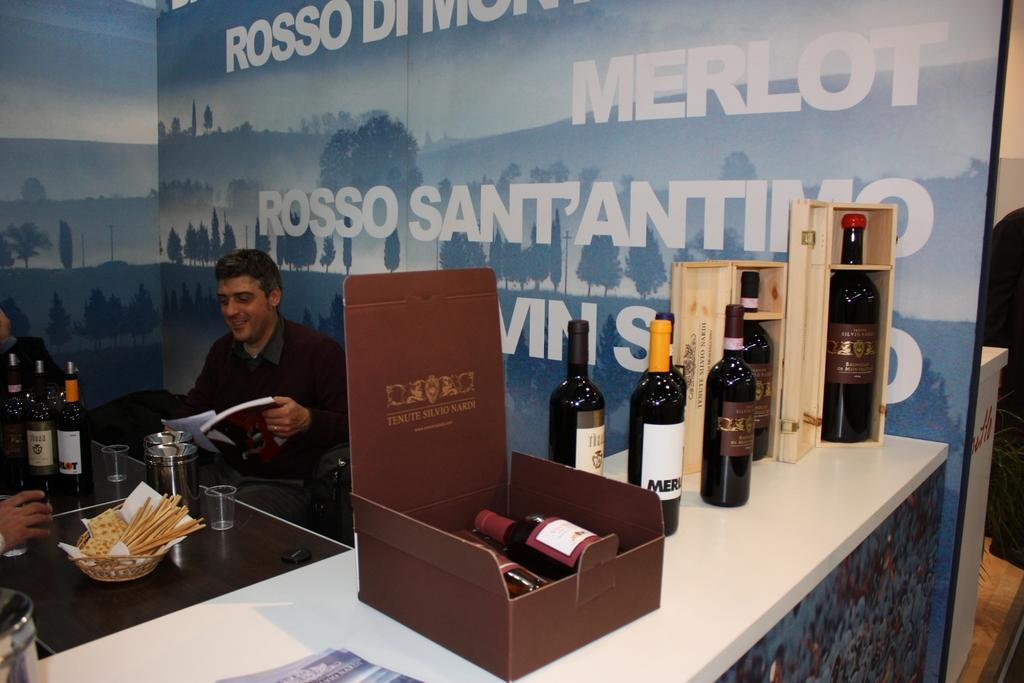<image>
Give a short and clear explanation of the subsequent image. A man behind a bar at a wine serving stand is holding a magazine. 